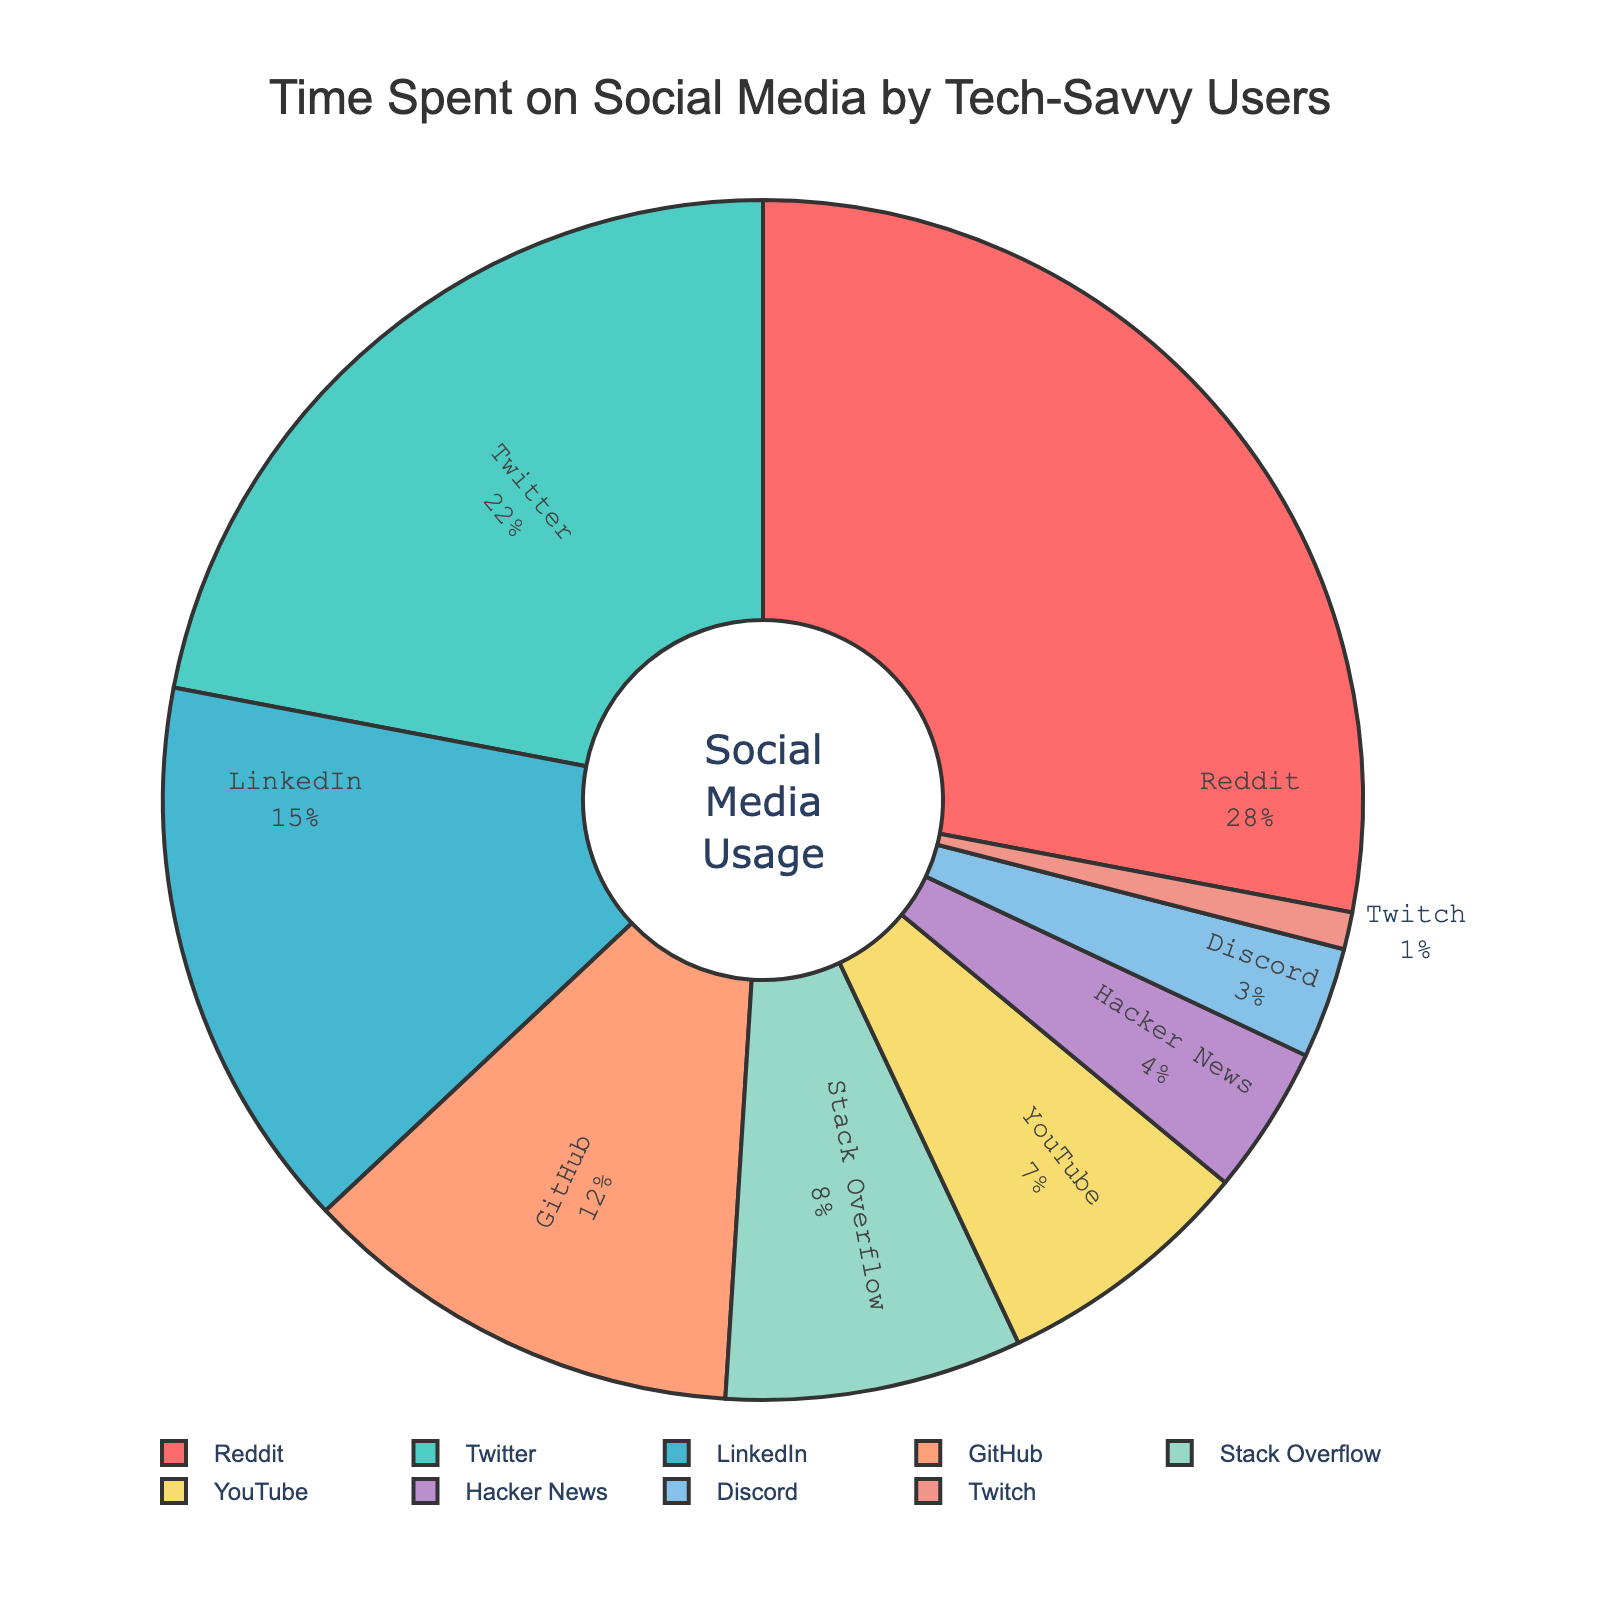Which platform do tech-savvy users spend the most time on? According to the pie chart, the largest section is labeled Reddit with 28% of the time spent.
Answer: Reddit What percentage of time is spent on Twitter compared to YouTube? Twitter accounts for 22% of the time, while YouTube accounts for 7%. So, they spend 15% more time on Twitter compared to YouTube.
Answer: 15% How much more time is spent on LinkedIn than on GitHub? LinkedIn has 15% and GitHub has 12%, so the difference is 15% - 12% = 3%.
Answer: 3% If we combine the time spent on Stack Overflow, Hacker News, Discord, and Twitch, what is the total percentage? Stack Overflow is 8%, Hacker News is 4%, Discord is 3%, and Twitch is 1%. Summing these up: 8 + 4 + 3 + 1 = 16%.
Answer: 16% Which platform has the smallest percentage of time spent and what is that percentage? The smallest section in the pie chart belongs to Twitch at 1%.
Answer: Twitch, 1% What is the combined percentage of time spent on platforms primarily used for coding-related activities (GitHub and Stack Overflow)? GitHub accounts for 12% and Stack Overflow accounts for 8%. Combined, this makes 12% + 8% = 20%.
Answer: 20% Is the percentage of time spent on Reddit more than the combined time spent on Discord, Hacker News, and Twitch? Reddit alone is 28%, while Discord is 3%, Hacker News is 4%, and Twitch is 1%. Combined, these make 3 + 4 + 1 = 8%. So yes, 28% is more than 8%.
Answer: Yes What is the percentage difference between the most and the least popular platforms? The most popular platform is Reddit at 28%, and the least popular is Twitch at 1%. The difference is 28% - 1% = 27%.
Answer: 27% Which platform's section is depicted with a light blue color? The pie chart shows Twitter labeled in light blue with 22% of time spent.
Answer: Twitter 